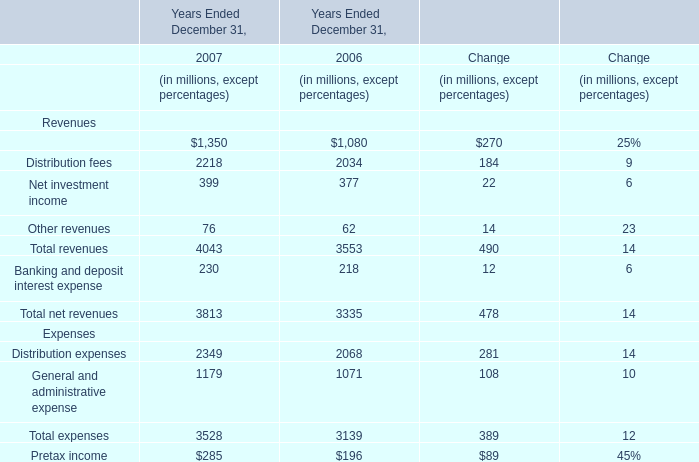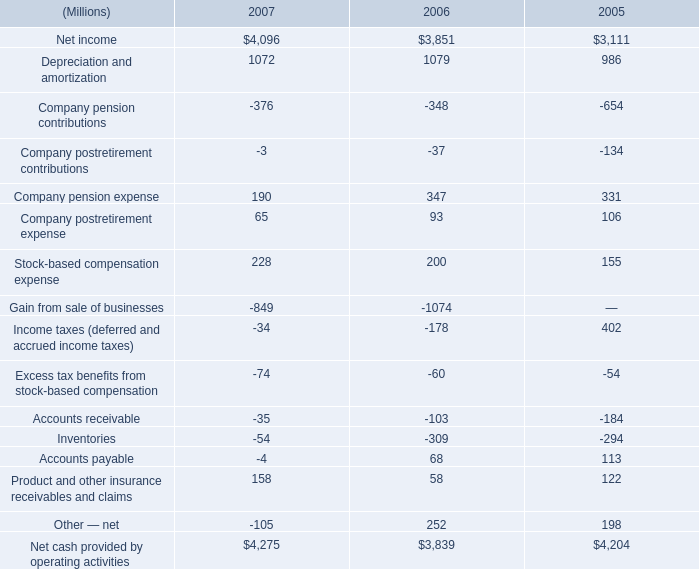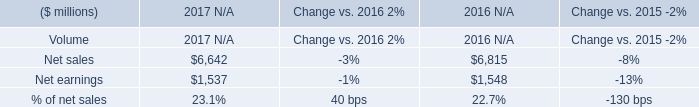What's the sum of Net sales of 2016 N/A, Net cash provided by operating activities of 2007, and Net income of 2005 ? 
Computations: ((6815.0 + 4275.0) + 3111.0)
Answer: 14201.0. 